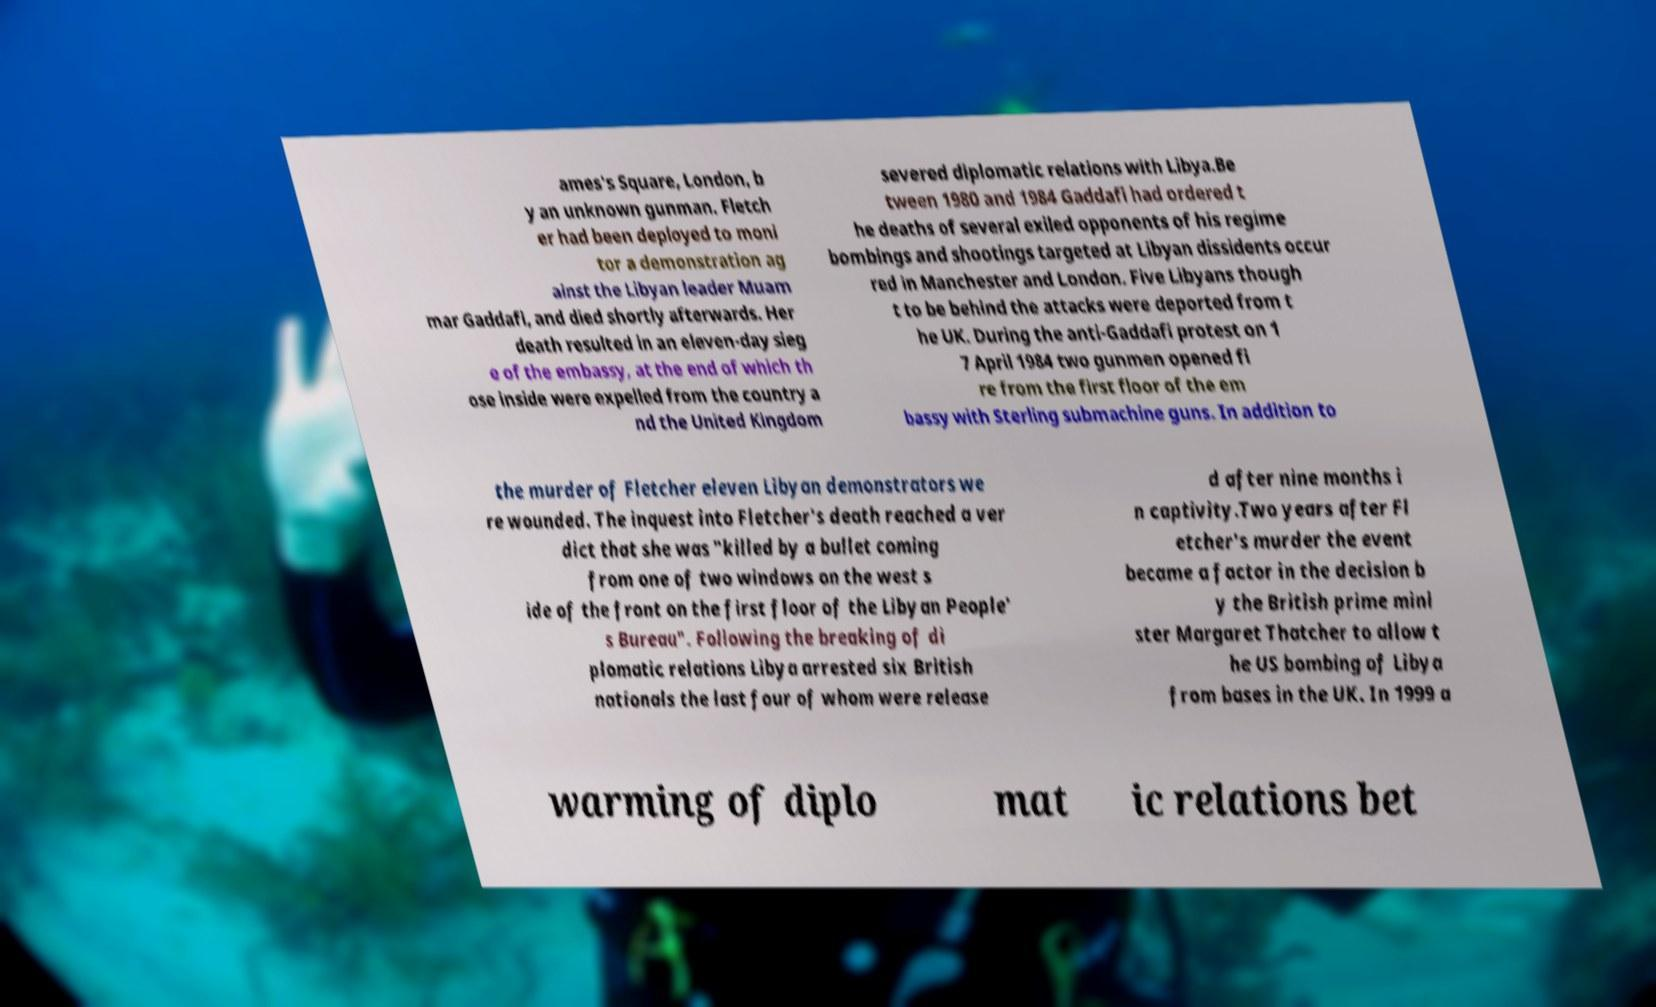Can you accurately transcribe the text from the provided image for me? ames's Square, London, b y an unknown gunman. Fletch er had been deployed to moni tor a demonstration ag ainst the Libyan leader Muam mar Gaddafi, and died shortly afterwards. Her death resulted in an eleven-day sieg e of the embassy, at the end of which th ose inside were expelled from the country a nd the United Kingdom severed diplomatic relations with Libya.Be tween 1980 and 1984 Gaddafi had ordered t he deaths of several exiled opponents of his regime bombings and shootings targeted at Libyan dissidents occur red in Manchester and London. Five Libyans though t to be behind the attacks were deported from t he UK. During the anti-Gaddafi protest on 1 7 April 1984 two gunmen opened fi re from the first floor of the em bassy with Sterling submachine guns. In addition to the murder of Fletcher eleven Libyan demonstrators we re wounded. The inquest into Fletcher's death reached a ver dict that she was "killed by a bullet coming from one of two windows on the west s ide of the front on the first floor of the Libyan People' s Bureau". Following the breaking of di plomatic relations Libya arrested six British nationals the last four of whom were release d after nine months i n captivity.Two years after Fl etcher's murder the event became a factor in the decision b y the British prime mini ster Margaret Thatcher to allow t he US bombing of Libya from bases in the UK. In 1999 a warming of diplo mat ic relations bet 